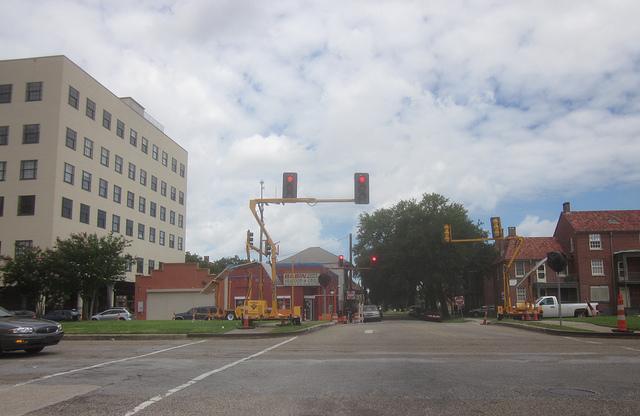How many red traffic lights are visible in this picture?
Give a very brief answer. 4. How many stories is the tallest building in the photo?
Give a very brief answer. 6. How many red lights are showing?
Give a very brief answer. 4. How many birds are pictured?
Give a very brief answer. 0. 